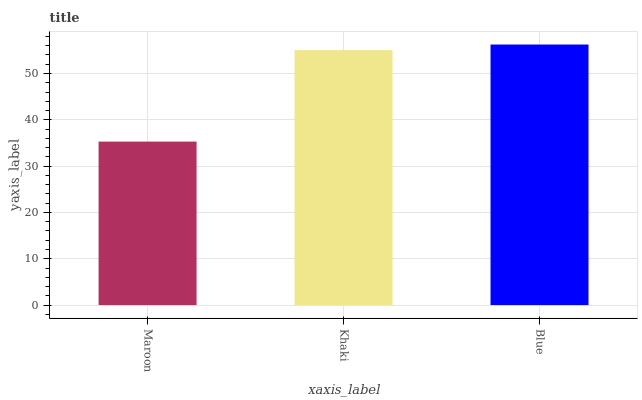Is Maroon the minimum?
Answer yes or no. Yes. Is Blue the maximum?
Answer yes or no. Yes. Is Khaki the minimum?
Answer yes or no. No. Is Khaki the maximum?
Answer yes or no. No. Is Khaki greater than Maroon?
Answer yes or no. Yes. Is Maroon less than Khaki?
Answer yes or no. Yes. Is Maroon greater than Khaki?
Answer yes or no. No. Is Khaki less than Maroon?
Answer yes or no. No. Is Khaki the high median?
Answer yes or no. Yes. Is Khaki the low median?
Answer yes or no. Yes. Is Maroon the high median?
Answer yes or no. No. Is Blue the low median?
Answer yes or no. No. 